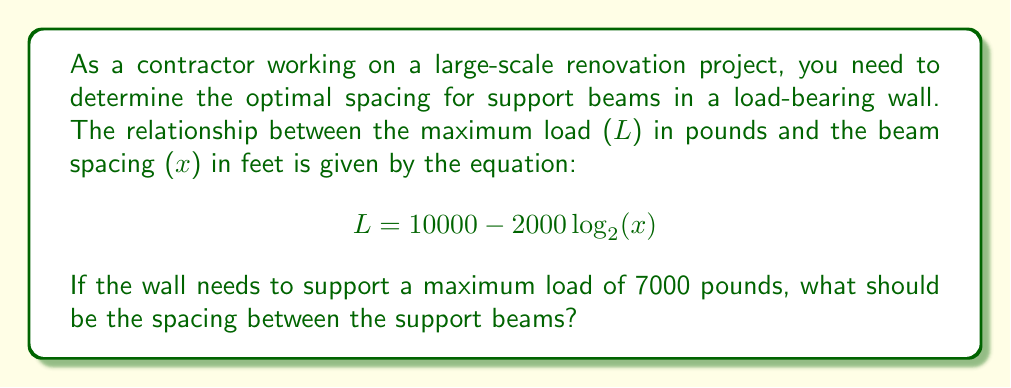Show me your answer to this math problem. Let's solve this problem step by step:

1) We're given the equation: $L = 10000 - 2000 \log_{2}(x)$
   Where L is the maximum load in pounds and x is the beam spacing in feet.

2) We need to find x when L = 7000 pounds. Let's substitute this into our equation:

   $7000 = 10000 - 2000 \log_{2}(x)$

3) Subtract 10000 from both sides:

   $-3000 = -2000 \log_{2}(x)$

4) Divide both sides by -2000:

   $1.5 = \log_{2}(x)$

5) To solve for x, we need to apply the inverse function (exponential) to both sides:

   $2^{1.5} = x$

6) Calculate this value:

   $x = 2^{1.5} \approx 2.8284$ feet

Therefore, the optimal spacing between support beams should be approximately 2.8284 feet.
Answer: $2^{1.5} \approx 2.8284$ feet 